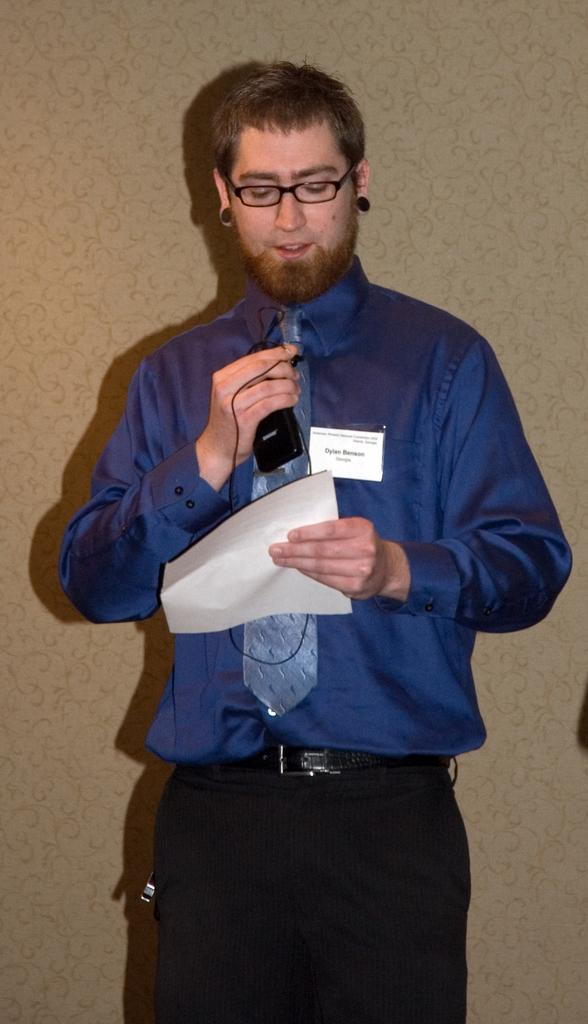What is the main subject of the image? There is a person in the image. What is the person wearing? The person is wearing a blue shirt and black pants. What is the person holding in their hands? The person is holding a paper and a mobile. What color is the background of the image? The background of the image is cream-colored. What type of leather is the person using to make a hat in the image? There is no leather or hat-making activity present in the image. Can you tell me how many friends the person has in the image? The image only shows one person, so it is not possible to determine the number of friends they have. 